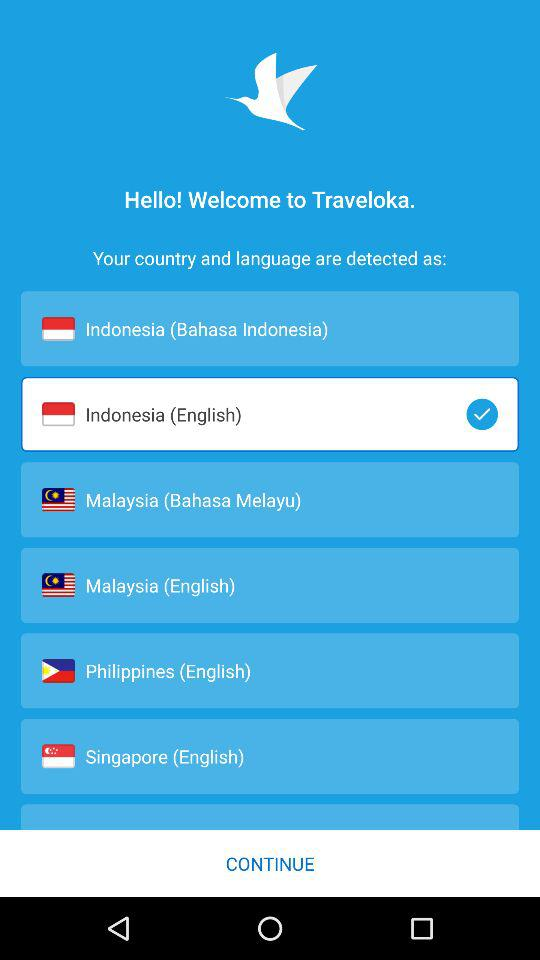What is the application name? The application name is "Traveloka". 